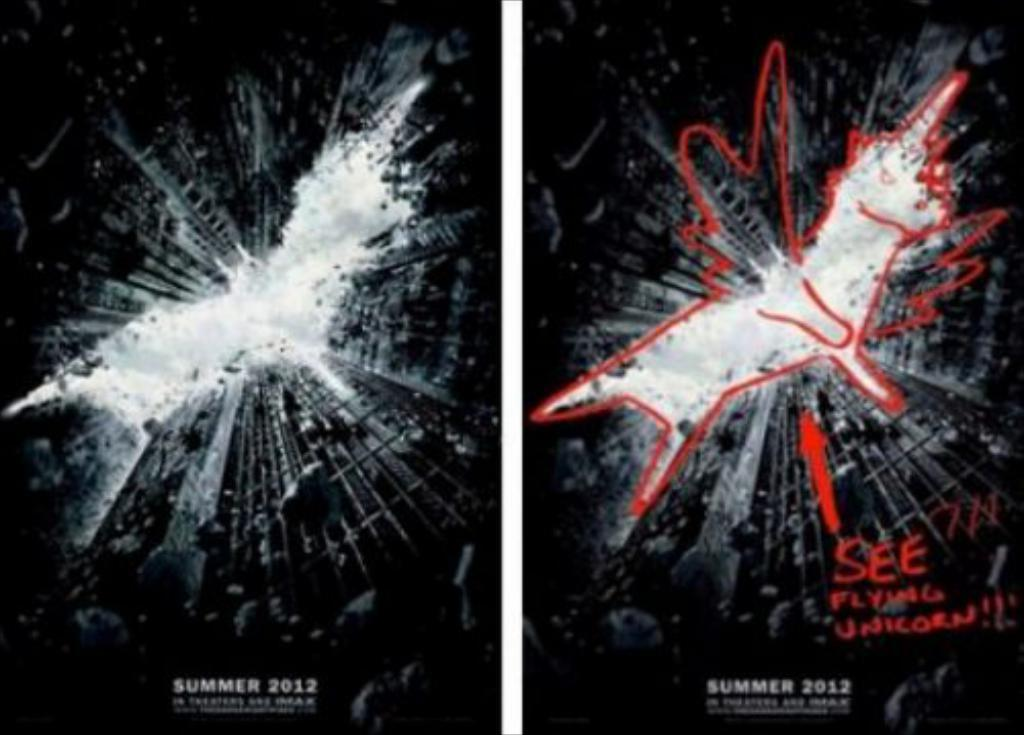<image>
Share a concise interpretation of the image provided. A pair of posters that say Summer 2012 at the bottom. 